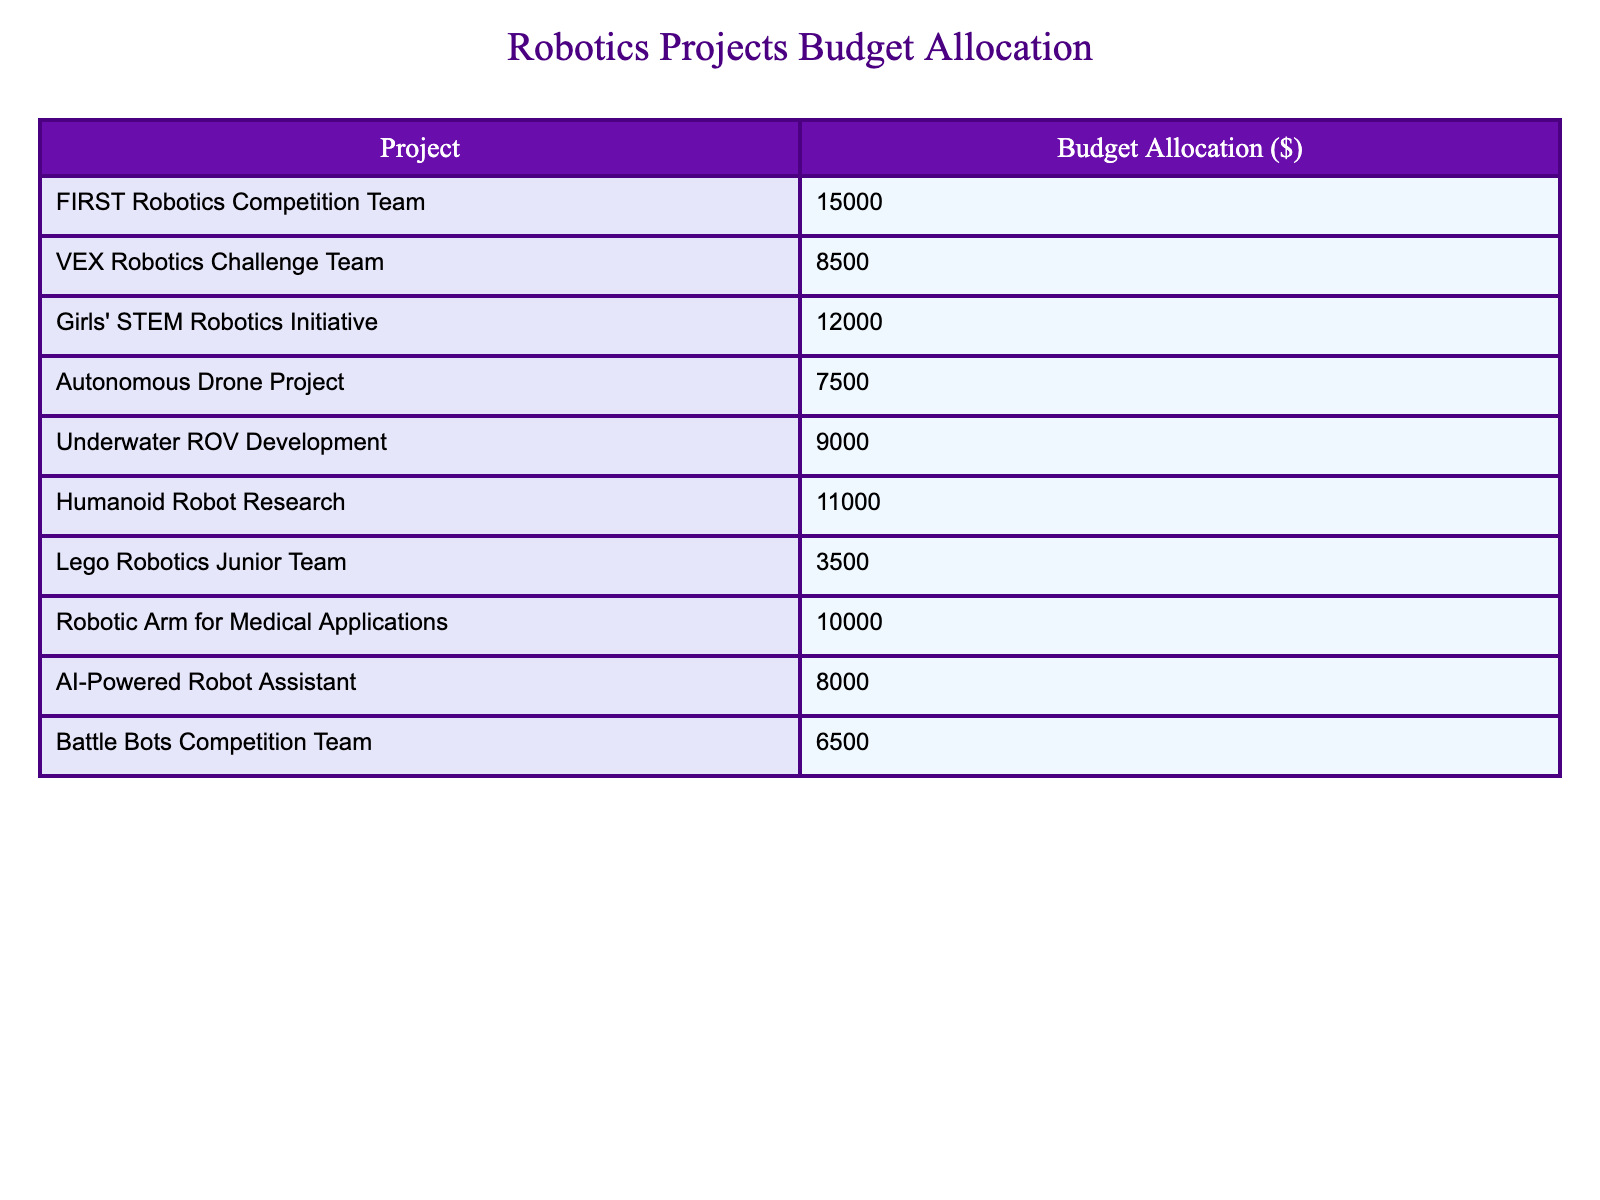What is the budget allocated for the Girls' STEM Robotics Initiative? The table shows that the budget allocated for the Girls' STEM Robotics Initiative is $12,000.
Answer: $12,000 Which robotics project has the highest budget allocation? By reviewing the budget allocations listed, the FIRST Robotics Competition Team, with a budget of $15,000, has the highest allocation.
Answer: FIRST Robotics Competition Team What is the total budget allocated for all projects listed in the table? Adding the budget allocations: 15000 + 8500 + 12000 + 7500 + 9000 + 11000 + 3500 + 10000 + 8000 + 6500 equals $79,000.
Answer: $79,000 Which project has a lower budget than the Lego Robotics Junior Team? The table shows that the Lego Robotics Junior Team has a budget of $3,500; no other project has a lower budget than this amount.
Answer: No project has a lower budget What is the average budget allocation for the robotics projects in the table? To find the average, sum the total budgets ($79,000) and divide by the number of projects (10), resulting in an average of $7,900.
Answer: $7,900 Is the budget for the Autonomous Drone Project greater than the average budget allocation? The budget for the Autonomous Drone Project is $7,500, which is less than the average budget of $7,900, confirming that it is not greater.
Answer: No What is the combined budget allocated for the Girls' STEM Robotics Initiative and the Humanoid Robot Research? Adding the budgets of the two projects: $12,000 (Girls' STEM Robotics Initiative) + $11,000 (Humanoid Robot Research) equals $23,000 combined.
Answer: $23,000 How much more budget is allocated to the FIRST Robotics Competition Team compared to the VEX Robotics Challenge Team? The FIRST Robotics Competition Team has a budget of $15,000 while the VEX Robotics Challenge Team has $8,500. The difference is $15,000 - $8,500 = $6,500.
Answer: $6,500 What fraction of the total budget is allocated to the Girls' STEM Robotics Initiative? The total budget is $79,000, and the Girls' STEM Robotics Initiative budget is $12,000. The fraction is 12,000/79,000 which simplifies to approximately 0.152.
Answer: Approximately 0.152 Which projects have a budget allocation of $8,000 or less? Reviewing the table, the projects with budgets of $8,000 or less are the Lego Robotics Junior Team ($3,500), AI-Powered Robot Assistant ($8,000), and Battle Bots Competition Team ($6,500).
Answer: Lego Robotics Junior Team, AI-Powered Robot Assistant, Battle Bots Competition Team 